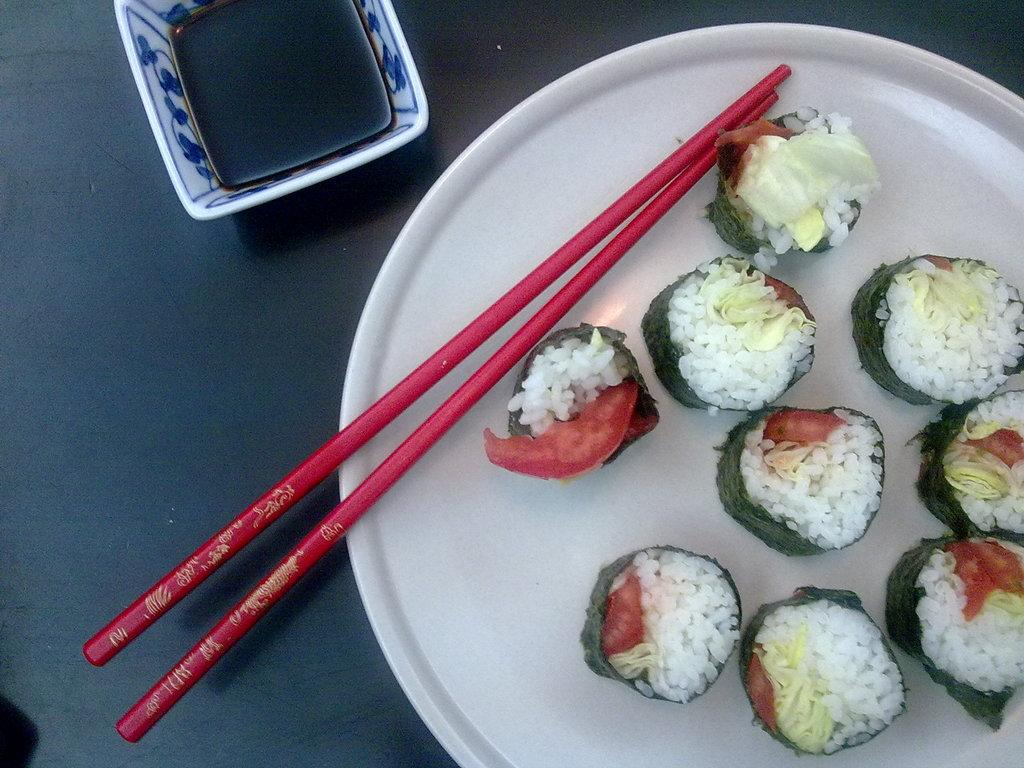What is on the plate in the image? There is food on a plate in the image. What utensil is visible in the image? Chopsticks are visible in the image. What is in the bowl in the image? There is a bowl with sauce in the image. Where are the food, chopsticks, and bowl located? The food, chopsticks, and bowl are on a table. How many pigs are visible in the image? There are no pigs present in the image. What type of stamp can be seen on the food in the image? There is no stamp on the food in the image. 